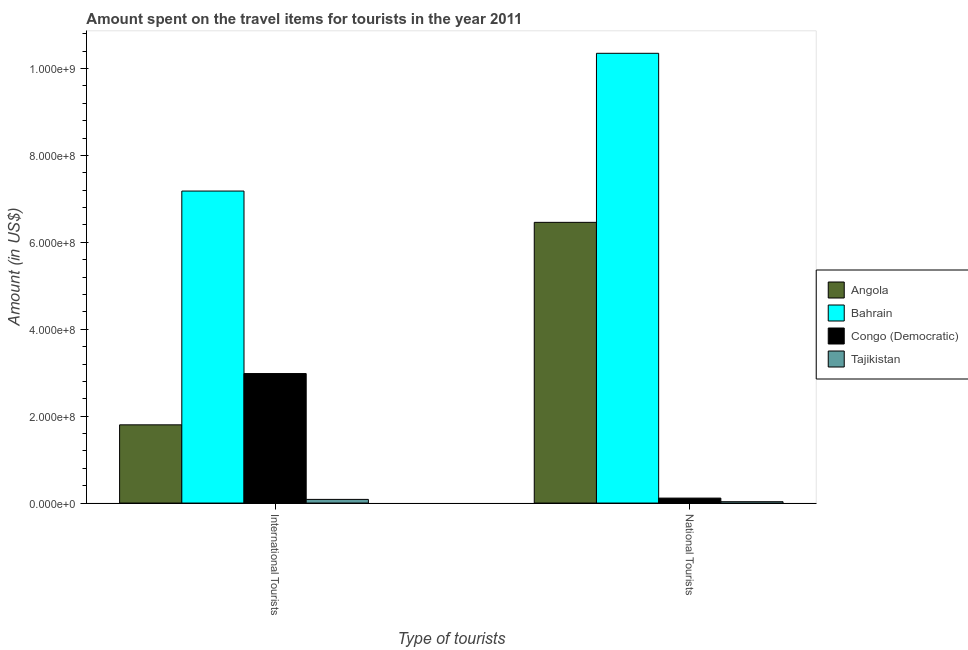How many bars are there on the 1st tick from the left?
Ensure brevity in your answer.  4. How many bars are there on the 1st tick from the right?
Your answer should be compact. 4. What is the label of the 2nd group of bars from the left?
Your response must be concise. National Tourists. What is the amount spent on travel items of international tourists in Tajikistan?
Offer a terse response. 8.40e+06. Across all countries, what is the maximum amount spent on travel items of national tourists?
Your answer should be very brief. 1.04e+09. Across all countries, what is the minimum amount spent on travel items of international tourists?
Ensure brevity in your answer.  8.40e+06. In which country was the amount spent on travel items of international tourists maximum?
Provide a succinct answer. Bahrain. In which country was the amount spent on travel items of international tourists minimum?
Give a very brief answer. Tajikistan. What is the total amount spent on travel items of national tourists in the graph?
Make the answer very short. 1.70e+09. What is the difference between the amount spent on travel items of national tourists in Angola and that in Bahrain?
Give a very brief answer. -3.89e+08. What is the difference between the amount spent on travel items of international tourists in Angola and the amount spent on travel items of national tourists in Congo (Democratic)?
Offer a terse response. 1.69e+08. What is the average amount spent on travel items of national tourists per country?
Your answer should be compact. 4.24e+08. What is the difference between the amount spent on travel items of national tourists and amount spent on travel items of international tourists in Bahrain?
Keep it short and to the point. 3.17e+08. What is the ratio of the amount spent on travel items of national tourists in Angola to that in Congo (Democratic)?
Your response must be concise. 56.67. What does the 1st bar from the left in National Tourists represents?
Your response must be concise. Angola. What does the 2nd bar from the right in National Tourists represents?
Provide a short and direct response. Congo (Democratic). How many bars are there?
Provide a succinct answer. 8. How many countries are there in the graph?
Give a very brief answer. 4. Are the values on the major ticks of Y-axis written in scientific E-notation?
Your answer should be very brief. Yes. How many legend labels are there?
Your answer should be compact. 4. How are the legend labels stacked?
Offer a very short reply. Vertical. What is the title of the graph?
Provide a succinct answer. Amount spent on the travel items for tourists in the year 2011. What is the label or title of the X-axis?
Give a very brief answer. Type of tourists. What is the Amount (in US$) in Angola in International Tourists?
Keep it short and to the point. 1.80e+08. What is the Amount (in US$) in Bahrain in International Tourists?
Offer a very short reply. 7.18e+08. What is the Amount (in US$) of Congo (Democratic) in International Tourists?
Your answer should be compact. 2.98e+08. What is the Amount (in US$) of Tajikistan in International Tourists?
Provide a succinct answer. 8.40e+06. What is the Amount (in US$) of Angola in National Tourists?
Offer a terse response. 6.46e+08. What is the Amount (in US$) of Bahrain in National Tourists?
Your answer should be very brief. 1.04e+09. What is the Amount (in US$) in Congo (Democratic) in National Tourists?
Keep it short and to the point. 1.14e+07. What is the Amount (in US$) of Tajikistan in National Tourists?
Provide a short and direct response. 3.10e+06. Across all Type of tourists, what is the maximum Amount (in US$) of Angola?
Your answer should be very brief. 6.46e+08. Across all Type of tourists, what is the maximum Amount (in US$) of Bahrain?
Ensure brevity in your answer.  1.04e+09. Across all Type of tourists, what is the maximum Amount (in US$) of Congo (Democratic)?
Your answer should be very brief. 2.98e+08. Across all Type of tourists, what is the maximum Amount (in US$) of Tajikistan?
Keep it short and to the point. 8.40e+06. Across all Type of tourists, what is the minimum Amount (in US$) in Angola?
Give a very brief answer. 1.80e+08. Across all Type of tourists, what is the minimum Amount (in US$) of Bahrain?
Provide a short and direct response. 7.18e+08. Across all Type of tourists, what is the minimum Amount (in US$) in Congo (Democratic)?
Provide a short and direct response. 1.14e+07. Across all Type of tourists, what is the minimum Amount (in US$) of Tajikistan?
Make the answer very short. 3.10e+06. What is the total Amount (in US$) in Angola in the graph?
Your answer should be very brief. 8.26e+08. What is the total Amount (in US$) in Bahrain in the graph?
Keep it short and to the point. 1.75e+09. What is the total Amount (in US$) of Congo (Democratic) in the graph?
Make the answer very short. 3.09e+08. What is the total Amount (in US$) in Tajikistan in the graph?
Your answer should be very brief. 1.15e+07. What is the difference between the Amount (in US$) in Angola in International Tourists and that in National Tourists?
Keep it short and to the point. -4.66e+08. What is the difference between the Amount (in US$) in Bahrain in International Tourists and that in National Tourists?
Keep it short and to the point. -3.17e+08. What is the difference between the Amount (in US$) in Congo (Democratic) in International Tourists and that in National Tourists?
Offer a terse response. 2.87e+08. What is the difference between the Amount (in US$) of Tajikistan in International Tourists and that in National Tourists?
Keep it short and to the point. 5.30e+06. What is the difference between the Amount (in US$) of Angola in International Tourists and the Amount (in US$) of Bahrain in National Tourists?
Keep it short and to the point. -8.55e+08. What is the difference between the Amount (in US$) of Angola in International Tourists and the Amount (in US$) of Congo (Democratic) in National Tourists?
Keep it short and to the point. 1.69e+08. What is the difference between the Amount (in US$) of Angola in International Tourists and the Amount (in US$) of Tajikistan in National Tourists?
Keep it short and to the point. 1.77e+08. What is the difference between the Amount (in US$) of Bahrain in International Tourists and the Amount (in US$) of Congo (Democratic) in National Tourists?
Your answer should be very brief. 7.07e+08. What is the difference between the Amount (in US$) of Bahrain in International Tourists and the Amount (in US$) of Tajikistan in National Tourists?
Provide a short and direct response. 7.15e+08. What is the difference between the Amount (in US$) of Congo (Democratic) in International Tourists and the Amount (in US$) of Tajikistan in National Tourists?
Offer a very short reply. 2.95e+08. What is the average Amount (in US$) of Angola per Type of tourists?
Your answer should be very brief. 4.13e+08. What is the average Amount (in US$) of Bahrain per Type of tourists?
Provide a succinct answer. 8.76e+08. What is the average Amount (in US$) in Congo (Democratic) per Type of tourists?
Your answer should be very brief. 1.55e+08. What is the average Amount (in US$) in Tajikistan per Type of tourists?
Provide a short and direct response. 5.75e+06. What is the difference between the Amount (in US$) of Angola and Amount (in US$) of Bahrain in International Tourists?
Ensure brevity in your answer.  -5.38e+08. What is the difference between the Amount (in US$) of Angola and Amount (in US$) of Congo (Democratic) in International Tourists?
Make the answer very short. -1.18e+08. What is the difference between the Amount (in US$) in Angola and Amount (in US$) in Tajikistan in International Tourists?
Provide a short and direct response. 1.72e+08. What is the difference between the Amount (in US$) in Bahrain and Amount (in US$) in Congo (Democratic) in International Tourists?
Make the answer very short. 4.20e+08. What is the difference between the Amount (in US$) of Bahrain and Amount (in US$) of Tajikistan in International Tourists?
Offer a terse response. 7.10e+08. What is the difference between the Amount (in US$) in Congo (Democratic) and Amount (in US$) in Tajikistan in International Tourists?
Offer a terse response. 2.90e+08. What is the difference between the Amount (in US$) of Angola and Amount (in US$) of Bahrain in National Tourists?
Provide a short and direct response. -3.89e+08. What is the difference between the Amount (in US$) of Angola and Amount (in US$) of Congo (Democratic) in National Tourists?
Make the answer very short. 6.35e+08. What is the difference between the Amount (in US$) of Angola and Amount (in US$) of Tajikistan in National Tourists?
Offer a very short reply. 6.43e+08. What is the difference between the Amount (in US$) in Bahrain and Amount (in US$) in Congo (Democratic) in National Tourists?
Provide a short and direct response. 1.02e+09. What is the difference between the Amount (in US$) of Bahrain and Amount (in US$) of Tajikistan in National Tourists?
Offer a terse response. 1.03e+09. What is the difference between the Amount (in US$) of Congo (Democratic) and Amount (in US$) of Tajikistan in National Tourists?
Give a very brief answer. 8.30e+06. What is the ratio of the Amount (in US$) in Angola in International Tourists to that in National Tourists?
Ensure brevity in your answer.  0.28. What is the ratio of the Amount (in US$) of Bahrain in International Tourists to that in National Tourists?
Offer a terse response. 0.69. What is the ratio of the Amount (in US$) of Congo (Democratic) in International Tourists to that in National Tourists?
Your answer should be very brief. 26.14. What is the ratio of the Amount (in US$) in Tajikistan in International Tourists to that in National Tourists?
Your answer should be compact. 2.71. What is the difference between the highest and the second highest Amount (in US$) of Angola?
Provide a succinct answer. 4.66e+08. What is the difference between the highest and the second highest Amount (in US$) of Bahrain?
Offer a very short reply. 3.17e+08. What is the difference between the highest and the second highest Amount (in US$) in Congo (Democratic)?
Ensure brevity in your answer.  2.87e+08. What is the difference between the highest and the second highest Amount (in US$) of Tajikistan?
Your answer should be very brief. 5.30e+06. What is the difference between the highest and the lowest Amount (in US$) in Angola?
Keep it short and to the point. 4.66e+08. What is the difference between the highest and the lowest Amount (in US$) of Bahrain?
Make the answer very short. 3.17e+08. What is the difference between the highest and the lowest Amount (in US$) in Congo (Democratic)?
Give a very brief answer. 2.87e+08. What is the difference between the highest and the lowest Amount (in US$) in Tajikistan?
Your answer should be compact. 5.30e+06. 